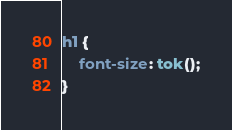<code> <loc_0><loc_0><loc_500><loc_500><_CSS_>h1 {
	font-size: tok();
}
</code> 